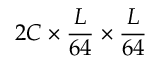Convert formula to latex. <formula><loc_0><loc_0><loc_500><loc_500>2 C \times \frac { L } { 6 4 } \times \frac { L } { 6 4 }</formula> 